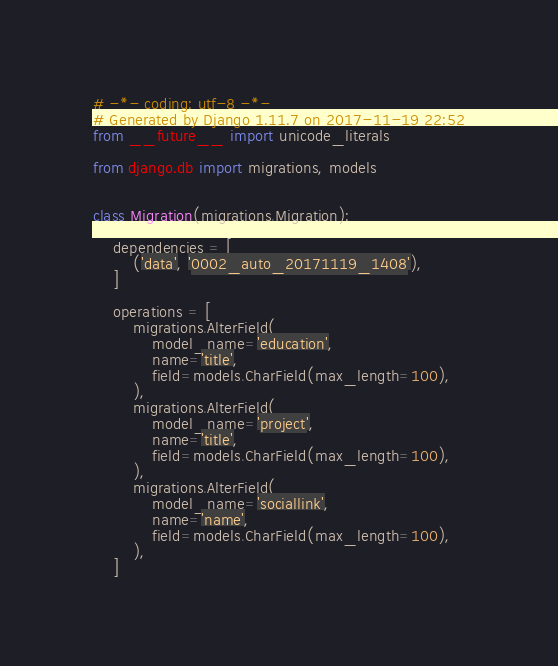Convert code to text. <code><loc_0><loc_0><loc_500><loc_500><_Python_># -*- coding: utf-8 -*-
# Generated by Django 1.11.7 on 2017-11-19 22:52
from __future__ import unicode_literals

from django.db import migrations, models


class Migration(migrations.Migration):

    dependencies = [
        ('data', '0002_auto_20171119_1408'),
    ]

    operations = [
        migrations.AlterField(
            model_name='education',
            name='title',
            field=models.CharField(max_length=100),
        ),
        migrations.AlterField(
            model_name='project',
            name='title',
            field=models.CharField(max_length=100),
        ),
        migrations.AlterField(
            model_name='sociallink',
            name='name',
            field=models.CharField(max_length=100),
        ),
    ]
</code> 